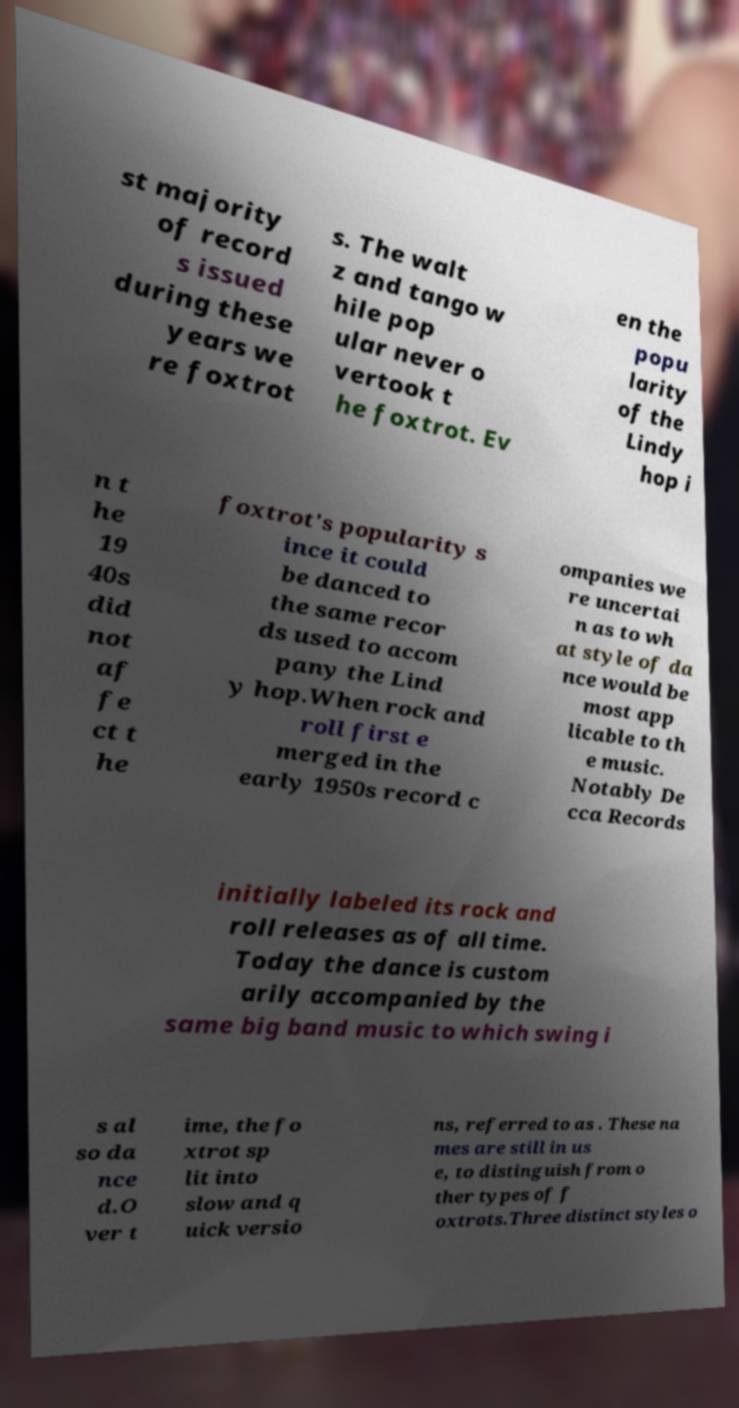Please read and relay the text visible in this image. What does it say? st majority of record s issued during these years we re foxtrot s. The walt z and tango w hile pop ular never o vertook t he foxtrot. Ev en the popu larity of the Lindy hop i n t he 19 40s did not af fe ct t he foxtrot's popularity s ince it could be danced to the same recor ds used to accom pany the Lind y hop.When rock and roll first e merged in the early 1950s record c ompanies we re uncertai n as to wh at style of da nce would be most app licable to th e music. Notably De cca Records initially labeled its rock and roll releases as of all time. Today the dance is custom arily accompanied by the same big band music to which swing i s al so da nce d.O ver t ime, the fo xtrot sp lit into slow and q uick versio ns, referred to as . These na mes are still in us e, to distinguish from o ther types of f oxtrots.Three distinct styles o 